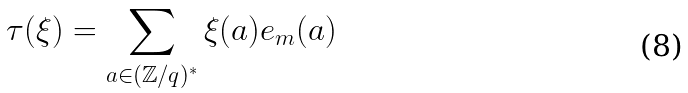Convert formula to latex. <formula><loc_0><loc_0><loc_500><loc_500>\tau ( \xi ) = \sum _ { a \in ( \mathbb { Z } / q ) ^ { * } } \xi ( a ) e _ { m } ( a )</formula> 